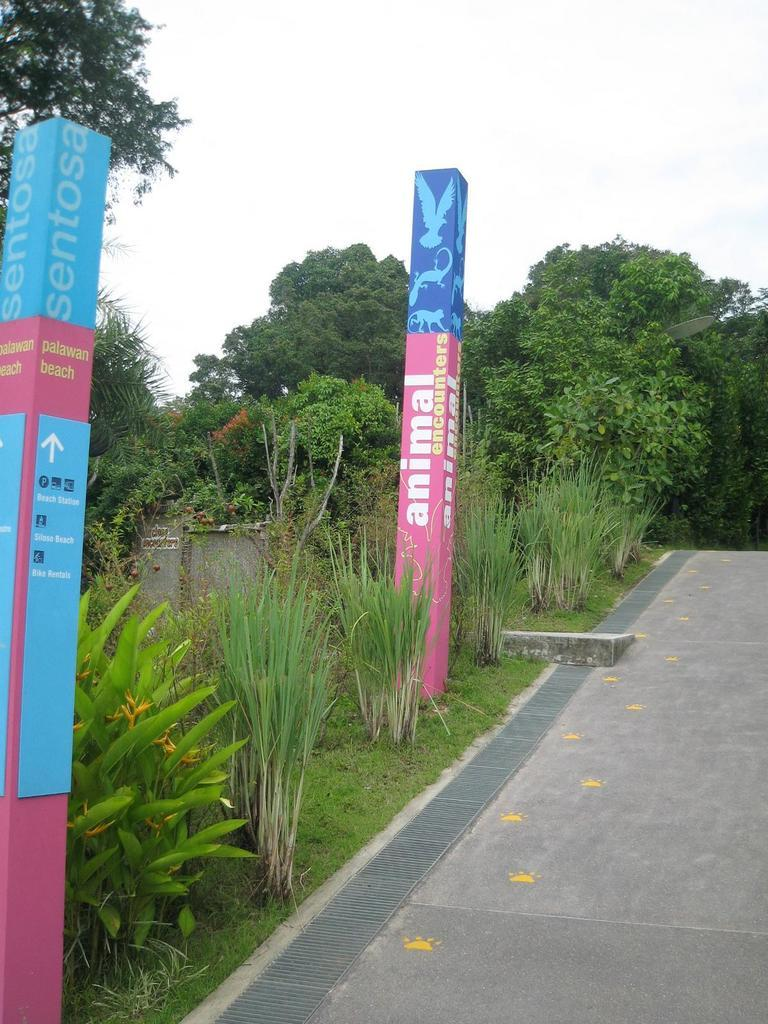What is the main feature of the image? There is a road in the image. What can be seen on the left side of the image? There are plants, grass, water, poles, trees, and a dish on the left side of the image. What is visible in the background of the image? The sky is visible in the image. What type of alarm can be heard going off in the image? There is no alarm present in the image, and therefore no sound can be heard. Can you describe the spark coming from the dish in the image? There is no spark coming from the dish in the image; it is simply a dish among the other items on the left side of the image. 